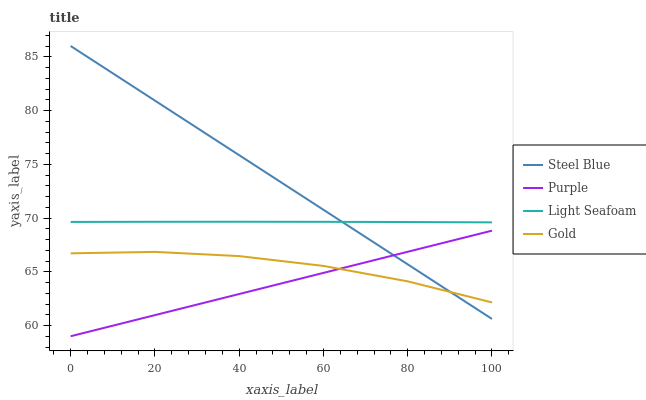Does Purple have the minimum area under the curve?
Answer yes or no. Yes. Does Steel Blue have the maximum area under the curve?
Answer yes or no. Yes. Does Light Seafoam have the minimum area under the curve?
Answer yes or no. No. Does Light Seafoam have the maximum area under the curve?
Answer yes or no. No. Is Steel Blue the smoothest?
Answer yes or no. Yes. Is Gold the roughest?
Answer yes or no. Yes. Is Light Seafoam the smoothest?
Answer yes or no. No. Is Light Seafoam the roughest?
Answer yes or no. No. Does Purple have the lowest value?
Answer yes or no. Yes. Does Steel Blue have the lowest value?
Answer yes or no. No. Does Steel Blue have the highest value?
Answer yes or no. Yes. Does Light Seafoam have the highest value?
Answer yes or no. No. Is Gold less than Light Seafoam?
Answer yes or no. Yes. Is Light Seafoam greater than Gold?
Answer yes or no. Yes. Does Light Seafoam intersect Steel Blue?
Answer yes or no. Yes. Is Light Seafoam less than Steel Blue?
Answer yes or no. No. Is Light Seafoam greater than Steel Blue?
Answer yes or no. No. Does Gold intersect Light Seafoam?
Answer yes or no. No. 